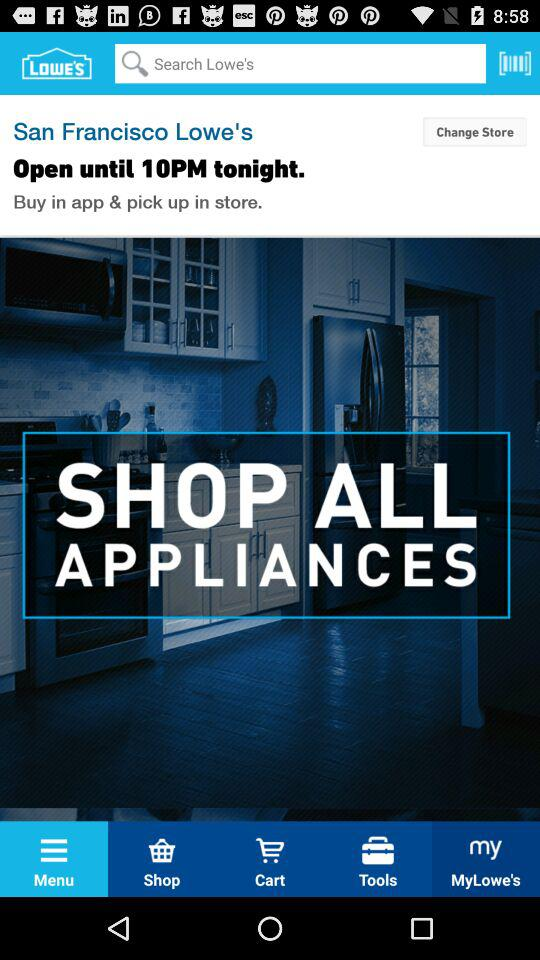What is the given location? The given location is San Francisco. 